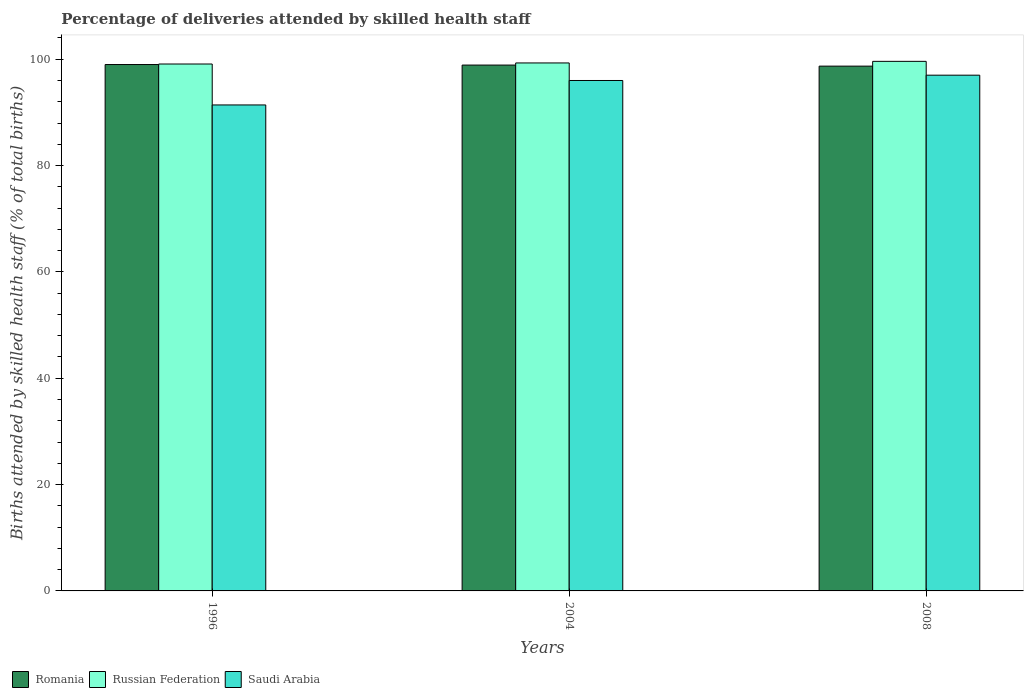Are the number of bars on each tick of the X-axis equal?
Offer a terse response. Yes. What is the label of the 2nd group of bars from the left?
Provide a short and direct response. 2004. What is the percentage of births attended by skilled health staff in Saudi Arabia in 2004?
Your answer should be compact. 96. Across all years, what is the minimum percentage of births attended by skilled health staff in Saudi Arabia?
Provide a succinct answer. 91.4. What is the total percentage of births attended by skilled health staff in Romania in the graph?
Your response must be concise. 296.6. What is the difference between the percentage of births attended by skilled health staff in Saudi Arabia in 1996 and that in 2008?
Keep it short and to the point. -5.6. What is the difference between the percentage of births attended by skilled health staff in Romania in 2008 and the percentage of births attended by skilled health staff in Russian Federation in 1996?
Give a very brief answer. -0.4. What is the average percentage of births attended by skilled health staff in Russian Federation per year?
Make the answer very short. 99.33. In the year 1996, what is the difference between the percentage of births attended by skilled health staff in Russian Federation and percentage of births attended by skilled health staff in Saudi Arabia?
Provide a short and direct response. 7.7. What is the ratio of the percentage of births attended by skilled health staff in Saudi Arabia in 1996 to that in 2008?
Provide a succinct answer. 0.94. What is the difference between the highest and the second highest percentage of births attended by skilled health staff in Romania?
Offer a terse response. 0.1. What is the difference between the highest and the lowest percentage of births attended by skilled health staff in Russian Federation?
Provide a short and direct response. 0.5. In how many years, is the percentage of births attended by skilled health staff in Russian Federation greater than the average percentage of births attended by skilled health staff in Russian Federation taken over all years?
Make the answer very short. 1. What does the 2nd bar from the left in 1996 represents?
Ensure brevity in your answer.  Russian Federation. What does the 1st bar from the right in 2004 represents?
Offer a terse response. Saudi Arabia. Is it the case that in every year, the sum of the percentage of births attended by skilled health staff in Saudi Arabia and percentage of births attended by skilled health staff in Romania is greater than the percentage of births attended by skilled health staff in Russian Federation?
Your answer should be very brief. Yes. What is the difference between two consecutive major ticks on the Y-axis?
Offer a terse response. 20. Does the graph contain grids?
Your answer should be compact. No. Where does the legend appear in the graph?
Your answer should be compact. Bottom left. How are the legend labels stacked?
Offer a terse response. Horizontal. What is the title of the graph?
Provide a short and direct response. Percentage of deliveries attended by skilled health staff. What is the label or title of the X-axis?
Provide a short and direct response. Years. What is the label or title of the Y-axis?
Provide a succinct answer. Births attended by skilled health staff (% of total births). What is the Births attended by skilled health staff (% of total births) in Romania in 1996?
Make the answer very short. 99. What is the Births attended by skilled health staff (% of total births) in Russian Federation in 1996?
Offer a terse response. 99.1. What is the Births attended by skilled health staff (% of total births) of Saudi Arabia in 1996?
Offer a very short reply. 91.4. What is the Births attended by skilled health staff (% of total births) of Romania in 2004?
Provide a short and direct response. 98.9. What is the Births attended by skilled health staff (% of total births) in Russian Federation in 2004?
Offer a terse response. 99.3. What is the Births attended by skilled health staff (% of total births) of Saudi Arabia in 2004?
Your response must be concise. 96. What is the Births attended by skilled health staff (% of total births) in Romania in 2008?
Your answer should be compact. 98.7. What is the Births attended by skilled health staff (% of total births) of Russian Federation in 2008?
Offer a terse response. 99.6. What is the Births attended by skilled health staff (% of total births) of Saudi Arabia in 2008?
Provide a short and direct response. 97. Across all years, what is the maximum Births attended by skilled health staff (% of total births) of Russian Federation?
Make the answer very short. 99.6. Across all years, what is the maximum Births attended by skilled health staff (% of total births) in Saudi Arabia?
Your response must be concise. 97. Across all years, what is the minimum Births attended by skilled health staff (% of total births) of Romania?
Keep it short and to the point. 98.7. Across all years, what is the minimum Births attended by skilled health staff (% of total births) of Russian Federation?
Keep it short and to the point. 99.1. Across all years, what is the minimum Births attended by skilled health staff (% of total births) of Saudi Arabia?
Offer a terse response. 91.4. What is the total Births attended by skilled health staff (% of total births) of Romania in the graph?
Your response must be concise. 296.6. What is the total Births attended by skilled health staff (% of total births) of Russian Federation in the graph?
Offer a very short reply. 298. What is the total Births attended by skilled health staff (% of total births) in Saudi Arabia in the graph?
Your answer should be compact. 284.4. What is the difference between the Births attended by skilled health staff (% of total births) of Romania in 1996 and that in 2004?
Your answer should be compact. 0.1. What is the difference between the Births attended by skilled health staff (% of total births) in Romania in 1996 and that in 2008?
Keep it short and to the point. 0.3. What is the difference between the Births attended by skilled health staff (% of total births) in Romania in 2004 and that in 2008?
Your response must be concise. 0.2. What is the difference between the Births attended by skilled health staff (% of total births) of Russian Federation in 2004 and that in 2008?
Provide a succinct answer. -0.3. What is the difference between the Births attended by skilled health staff (% of total births) in Saudi Arabia in 2004 and that in 2008?
Ensure brevity in your answer.  -1. What is the difference between the Births attended by skilled health staff (% of total births) of Russian Federation in 1996 and the Births attended by skilled health staff (% of total births) of Saudi Arabia in 2008?
Give a very brief answer. 2.1. What is the difference between the Births attended by skilled health staff (% of total births) of Romania in 2004 and the Births attended by skilled health staff (% of total births) of Saudi Arabia in 2008?
Your response must be concise. 1.9. What is the average Births attended by skilled health staff (% of total births) of Romania per year?
Provide a short and direct response. 98.87. What is the average Births attended by skilled health staff (% of total births) of Russian Federation per year?
Make the answer very short. 99.33. What is the average Births attended by skilled health staff (% of total births) of Saudi Arabia per year?
Your answer should be compact. 94.8. In the year 1996, what is the difference between the Births attended by skilled health staff (% of total births) of Romania and Births attended by skilled health staff (% of total births) of Russian Federation?
Give a very brief answer. -0.1. In the year 2004, what is the difference between the Births attended by skilled health staff (% of total births) in Romania and Births attended by skilled health staff (% of total births) in Russian Federation?
Your answer should be compact. -0.4. In the year 2004, what is the difference between the Births attended by skilled health staff (% of total births) of Russian Federation and Births attended by skilled health staff (% of total births) of Saudi Arabia?
Offer a terse response. 3.3. In the year 2008, what is the difference between the Births attended by skilled health staff (% of total births) of Romania and Births attended by skilled health staff (% of total births) of Russian Federation?
Your answer should be very brief. -0.9. In the year 2008, what is the difference between the Births attended by skilled health staff (% of total births) in Russian Federation and Births attended by skilled health staff (% of total births) in Saudi Arabia?
Give a very brief answer. 2.6. What is the ratio of the Births attended by skilled health staff (% of total births) in Romania in 1996 to that in 2004?
Your answer should be very brief. 1. What is the ratio of the Births attended by skilled health staff (% of total births) in Russian Federation in 1996 to that in 2004?
Make the answer very short. 1. What is the ratio of the Births attended by skilled health staff (% of total births) in Saudi Arabia in 1996 to that in 2004?
Ensure brevity in your answer.  0.95. What is the ratio of the Births attended by skilled health staff (% of total births) of Russian Federation in 1996 to that in 2008?
Offer a very short reply. 0.99. What is the ratio of the Births attended by skilled health staff (% of total births) of Saudi Arabia in 1996 to that in 2008?
Provide a succinct answer. 0.94. What is the ratio of the Births attended by skilled health staff (% of total births) of Russian Federation in 2004 to that in 2008?
Your answer should be compact. 1. What is the difference between the highest and the second highest Births attended by skilled health staff (% of total births) of Romania?
Your answer should be compact. 0.1. What is the difference between the highest and the second highest Births attended by skilled health staff (% of total births) of Saudi Arabia?
Your answer should be very brief. 1. What is the difference between the highest and the lowest Births attended by skilled health staff (% of total births) of Romania?
Ensure brevity in your answer.  0.3. What is the difference between the highest and the lowest Births attended by skilled health staff (% of total births) of Saudi Arabia?
Your answer should be compact. 5.6. 